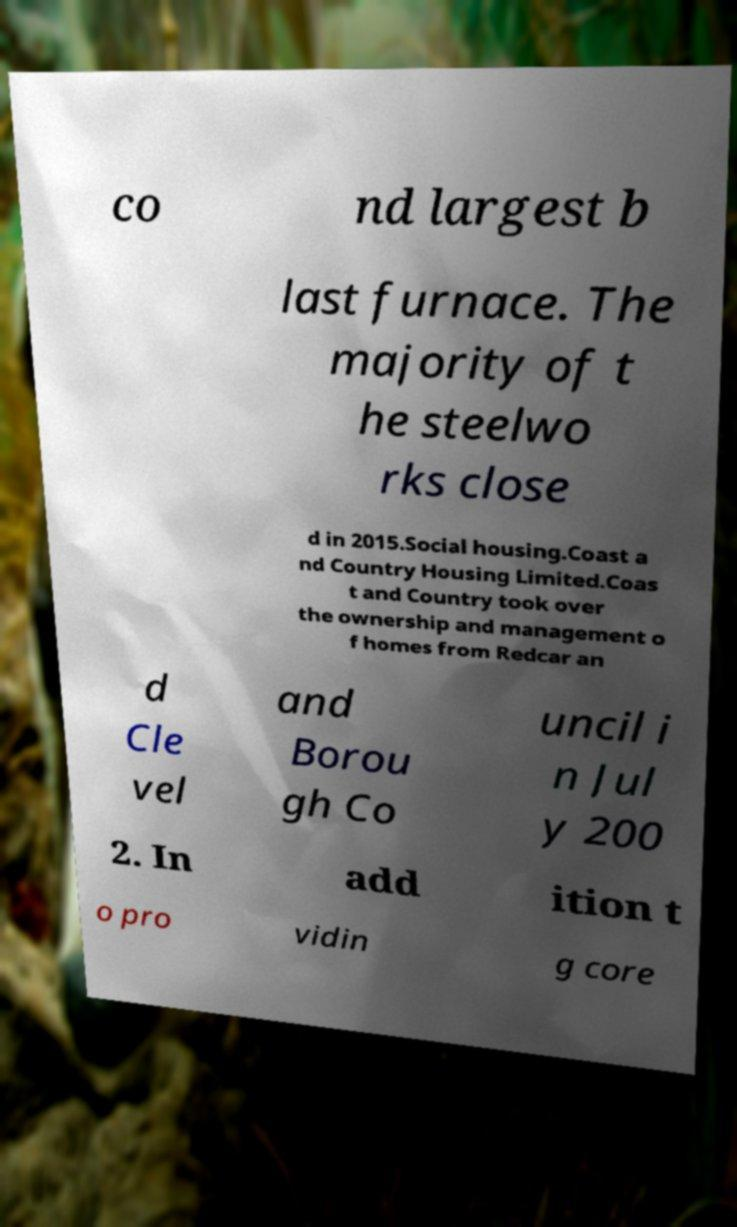What messages or text are displayed in this image? I need them in a readable, typed format. co nd largest b last furnace. The majority of t he steelwo rks close d in 2015.Social housing.Coast a nd Country Housing Limited.Coas t and Country took over the ownership and management o f homes from Redcar an d Cle vel and Borou gh Co uncil i n Jul y 200 2. In add ition t o pro vidin g core 